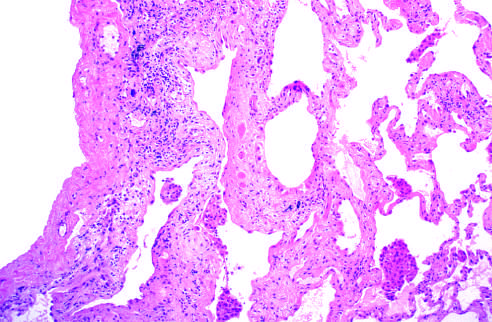how is the fibrosis, which varies in intensity?
Answer the question using a single word or phrase. More pronounced subpleural region 